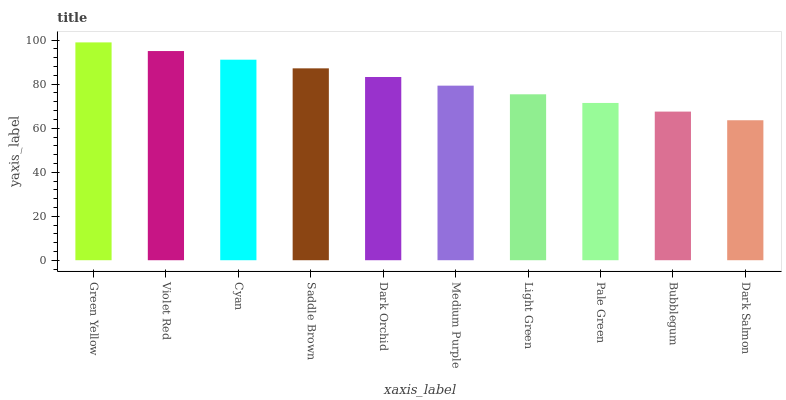Is Dark Salmon the minimum?
Answer yes or no. Yes. Is Green Yellow the maximum?
Answer yes or no. Yes. Is Violet Red the minimum?
Answer yes or no. No. Is Violet Red the maximum?
Answer yes or no. No. Is Green Yellow greater than Violet Red?
Answer yes or no. Yes. Is Violet Red less than Green Yellow?
Answer yes or no. Yes. Is Violet Red greater than Green Yellow?
Answer yes or no. No. Is Green Yellow less than Violet Red?
Answer yes or no. No. Is Dark Orchid the high median?
Answer yes or no. Yes. Is Medium Purple the low median?
Answer yes or no. Yes. Is Saddle Brown the high median?
Answer yes or no. No. Is Dark Salmon the low median?
Answer yes or no. No. 